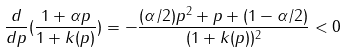Convert formula to latex. <formula><loc_0><loc_0><loc_500><loc_500>\frac { d } { d p } ( \frac { 1 + \alpha p } { 1 + k ( p ) } ) = - \frac { ( \alpha / 2 ) p ^ { 2 } + p + ( 1 - \alpha / 2 ) } { ( 1 + k ( p ) ) ^ { 2 } } < 0</formula> 